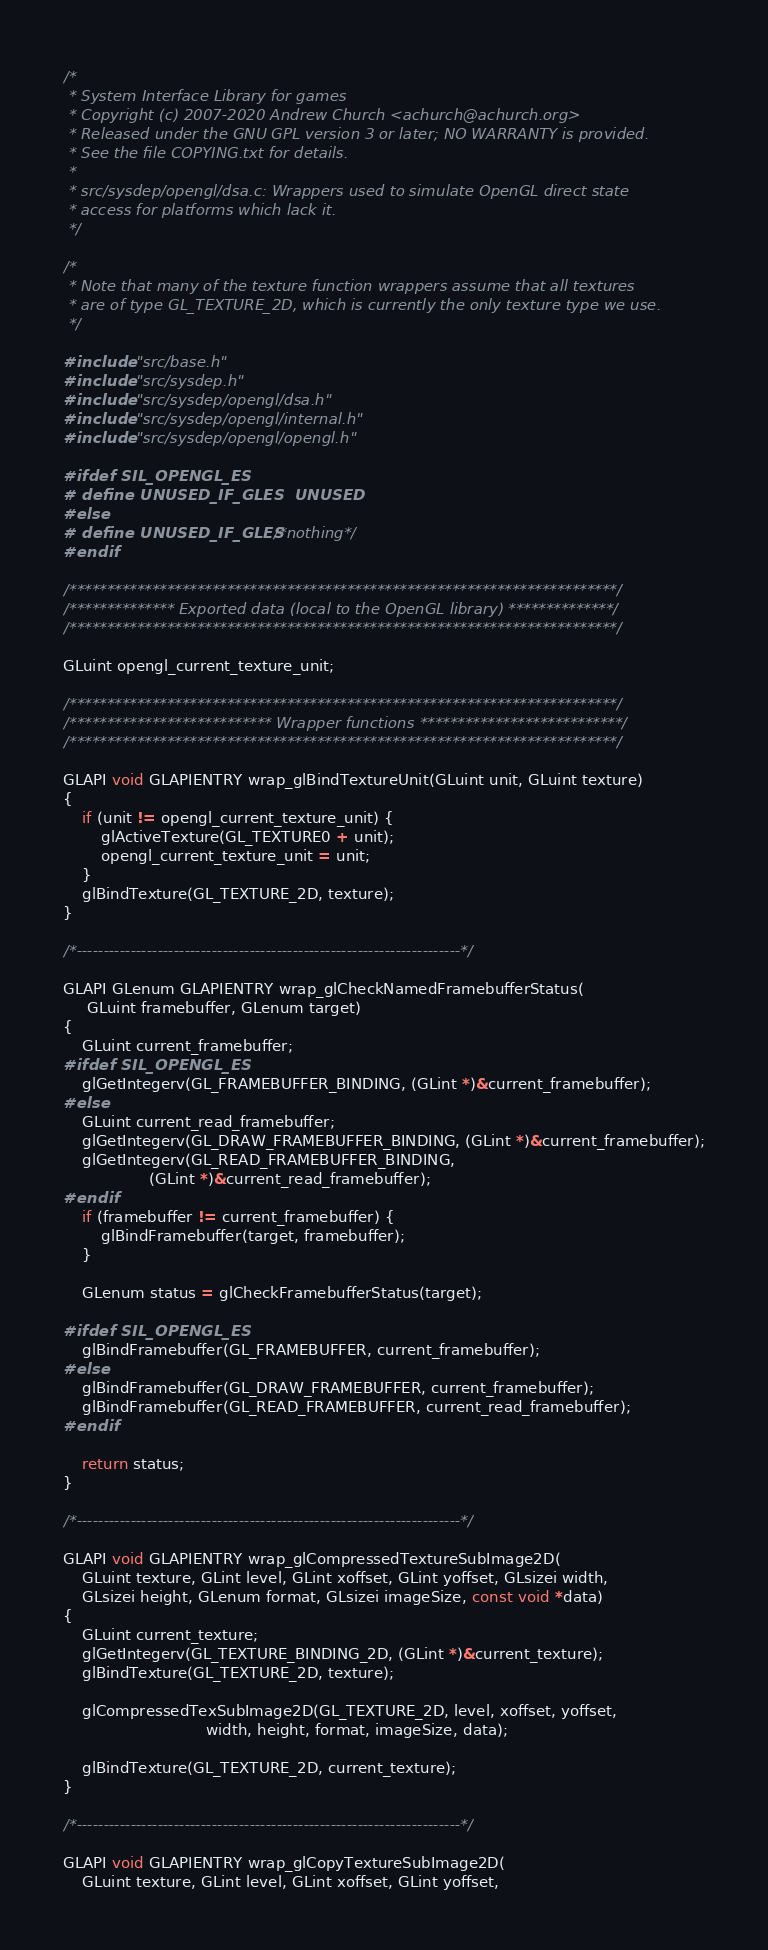Convert code to text. <code><loc_0><loc_0><loc_500><loc_500><_C_>/*
 * System Interface Library for games
 * Copyright (c) 2007-2020 Andrew Church <achurch@achurch.org>
 * Released under the GNU GPL version 3 or later; NO WARRANTY is provided.
 * See the file COPYING.txt for details.
 *
 * src/sysdep/opengl/dsa.c: Wrappers used to simulate OpenGL direct state
 * access for platforms which lack it.
 */

/*
 * Note that many of the texture function wrappers assume that all textures
 * are of type GL_TEXTURE_2D, which is currently the only texture type we use.
 */

#include "src/base.h"
#include "src/sysdep.h"
#include "src/sysdep/opengl/dsa.h"
#include "src/sysdep/opengl/internal.h"
#include "src/sysdep/opengl/opengl.h"

#ifdef SIL_OPENGL_ES
# define UNUSED_IF_GLES  UNUSED
#else
# define UNUSED_IF_GLES  /*nothing*/
#endif

/*************************************************************************/
/************** Exported data (local to the OpenGL library) **************/
/*************************************************************************/

GLuint opengl_current_texture_unit;

/*************************************************************************/
/*************************** Wrapper functions ***************************/
/*************************************************************************/

GLAPI void GLAPIENTRY wrap_glBindTextureUnit(GLuint unit, GLuint texture)
{
    if (unit != opengl_current_texture_unit) {
        glActiveTexture(GL_TEXTURE0 + unit);
        opengl_current_texture_unit = unit;
    }
    glBindTexture(GL_TEXTURE_2D, texture);
}

/*-----------------------------------------------------------------------*/

GLAPI GLenum GLAPIENTRY wrap_glCheckNamedFramebufferStatus(
     GLuint framebuffer, GLenum target)
{
    GLuint current_framebuffer;
#ifdef SIL_OPENGL_ES
    glGetIntegerv(GL_FRAMEBUFFER_BINDING, (GLint *)&current_framebuffer);
#else
    GLuint current_read_framebuffer;
    glGetIntegerv(GL_DRAW_FRAMEBUFFER_BINDING, (GLint *)&current_framebuffer);
    glGetIntegerv(GL_READ_FRAMEBUFFER_BINDING,
                  (GLint *)&current_read_framebuffer);
#endif
    if (framebuffer != current_framebuffer) {
        glBindFramebuffer(target, framebuffer);
    }

    GLenum status = glCheckFramebufferStatus(target);

#ifdef SIL_OPENGL_ES
    glBindFramebuffer(GL_FRAMEBUFFER, current_framebuffer);
#else
    glBindFramebuffer(GL_DRAW_FRAMEBUFFER, current_framebuffer);
    glBindFramebuffer(GL_READ_FRAMEBUFFER, current_read_framebuffer);
#endif

    return status;
}

/*-----------------------------------------------------------------------*/

GLAPI void GLAPIENTRY wrap_glCompressedTextureSubImage2D(
    GLuint texture, GLint level, GLint xoffset, GLint yoffset, GLsizei width,
    GLsizei height, GLenum format, GLsizei imageSize, const void *data)
{
    GLuint current_texture;
    glGetIntegerv(GL_TEXTURE_BINDING_2D, (GLint *)&current_texture);
    glBindTexture(GL_TEXTURE_2D, texture);

    glCompressedTexSubImage2D(GL_TEXTURE_2D, level, xoffset, yoffset,
                              width, height, format, imageSize, data);

    glBindTexture(GL_TEXTURE_2D, current_texture);
}

/*-----------------------------------------------------------------------*/

GLAPI void GLAPIENTRY wrap_glCopyTextureSubImage2D(
    GLuint texture, GLint level, GLint xoffset, GLint yoffset,</code> 